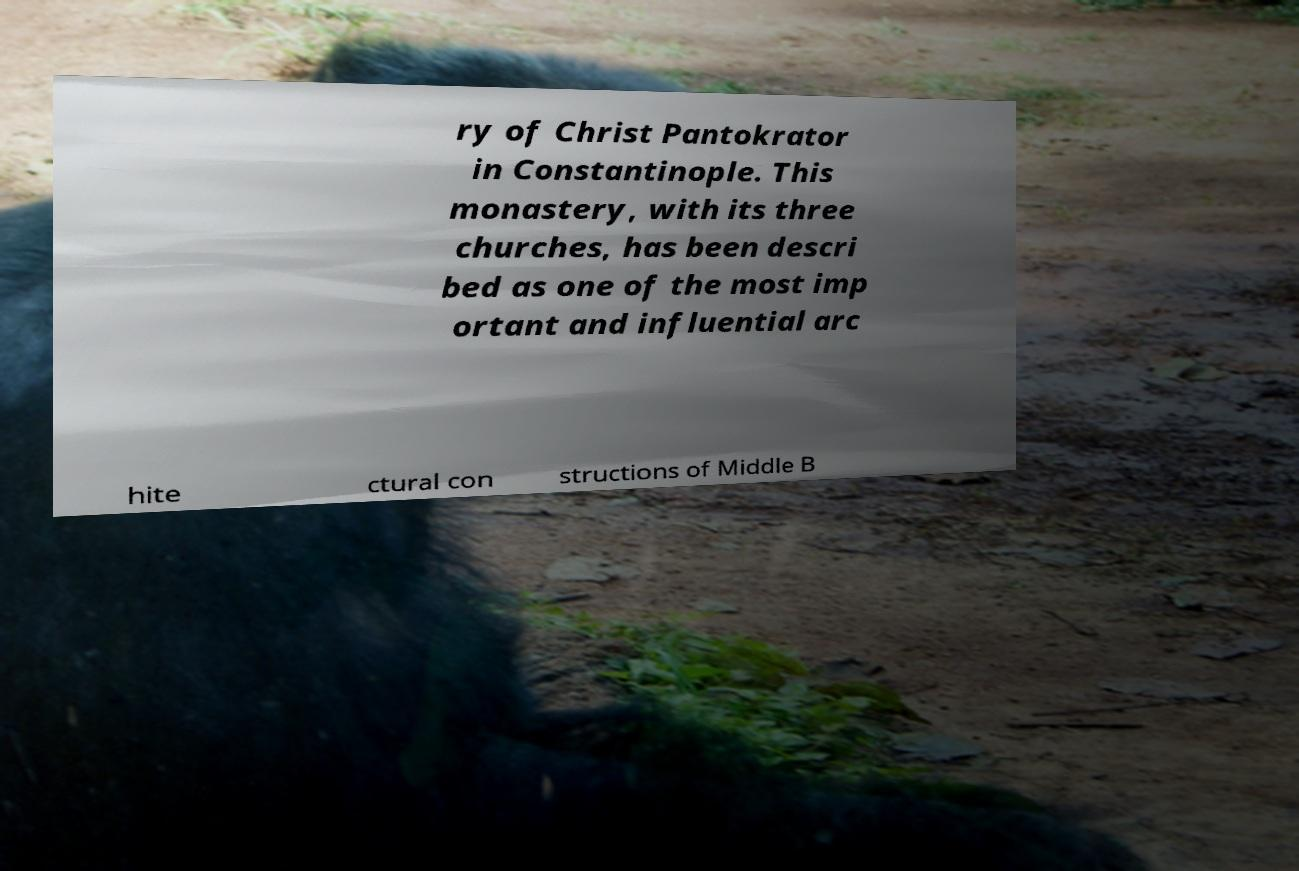Can you accurately transcribe the text from the provided image for me? ry of Christ Pantokrator in Constantinople. This monastery, with its three churches, has been descri bed as one of the most imp ortant and influential arc hite ctural con structions of Middle B 